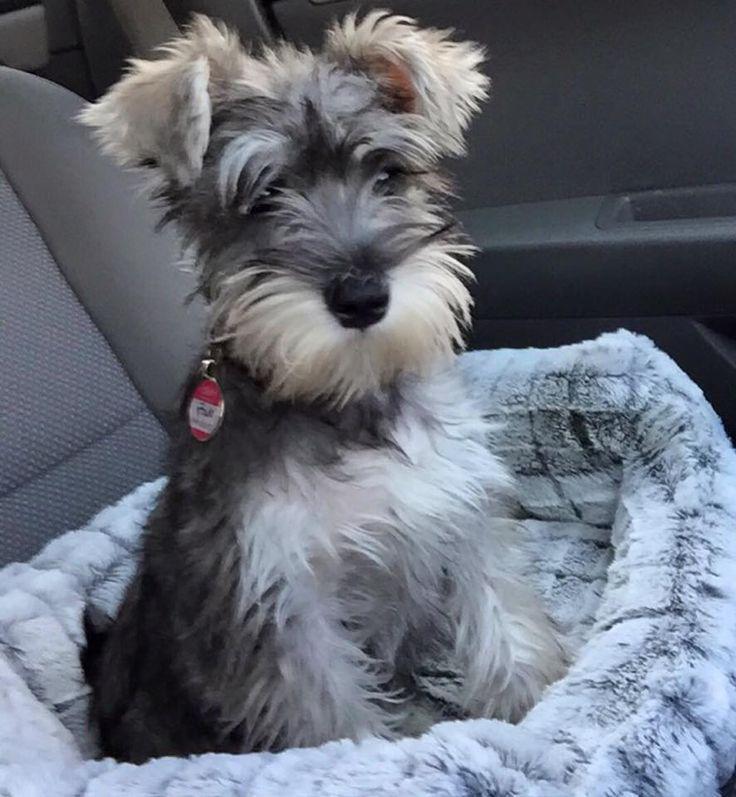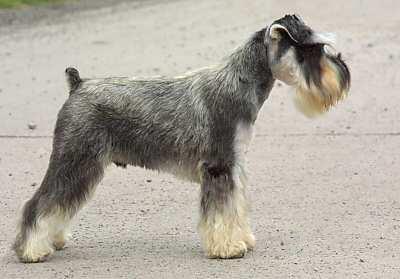The first image is the image on the left, the second image is the image on the right. Examine the images to the left and right. Is the description "There is a dog walking on the pavement in the right image." accurate? Answer yes or no. Yes. The first image is the image on the left, the second image is the image on the right. Examine the images to the left and right. Is the description "An image shows a schnauzer with bright green foliage." accurate? Answer yes or no. No. The first image is the image on the left, the second image is the image on the right. Assess this claim about the two images: "The dog in the image on the left is indoors". Correct or not? Answer yes or no. Yes. 